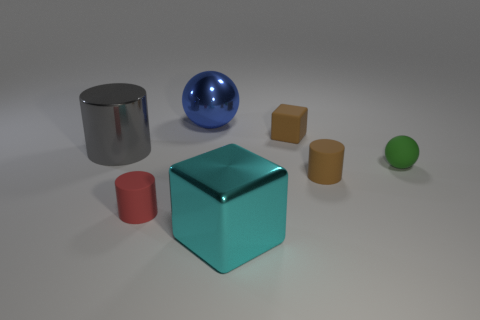Add 3 big metallic objects. How many objects exist? 10 Subtract all cubes. How many objects are left? 5 Add 4 metal things. How many metal things exist? 7 Subtract 0 yellow cylinders. How many objects are left? 7 Subtract all small red rubber objects. Subtract all large gray shiny things. How many objects are left? 5 Add 1 red rubber cylinders. How many red rubber cylinders are left? 2 